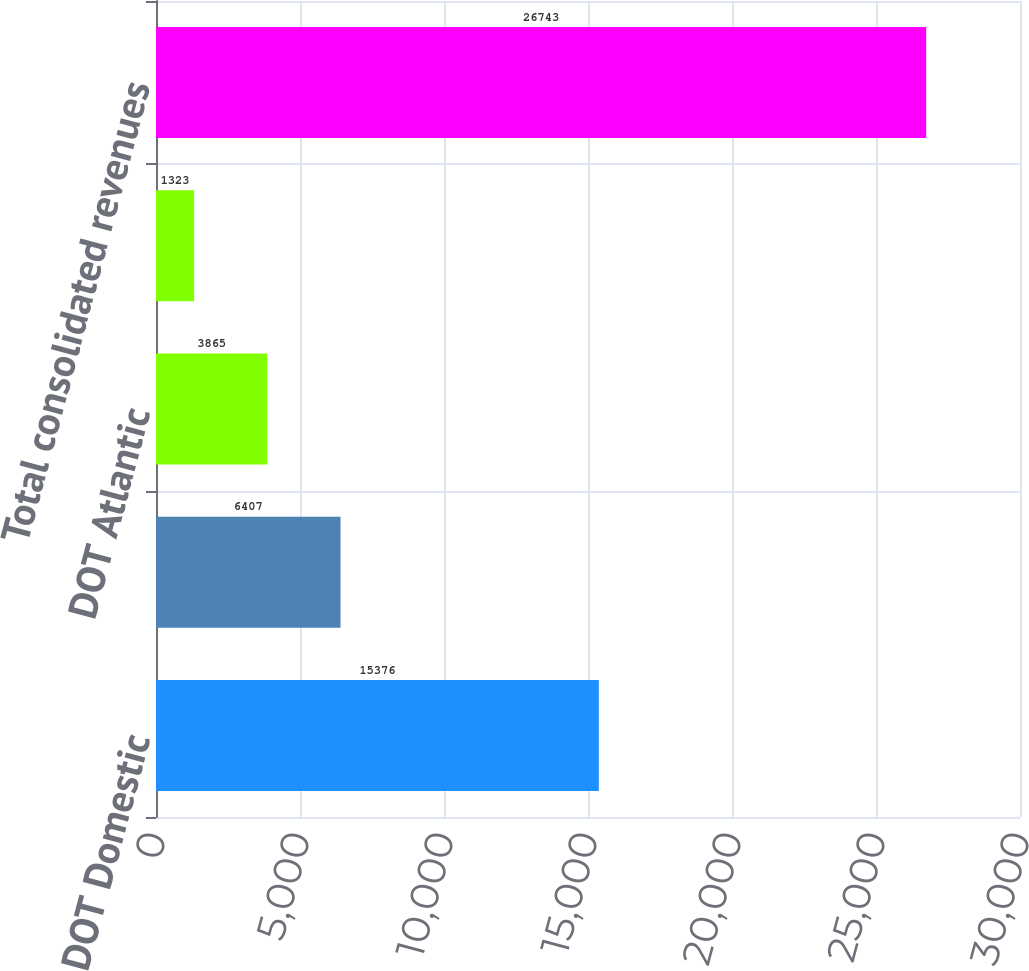<chart> <loc_0><loc_0><loc_500><loc_500><bar_chart><fcel>DOT Domestic<fcel>DOT Latin America<fcel>DOT Atlantic<fcel>DOT Pacific<fcel>Total consolidated revenues<nl><fcel>15376<fcel>6407<fcel>3865<fcel>1323<fcel>26743<nl></chart> 